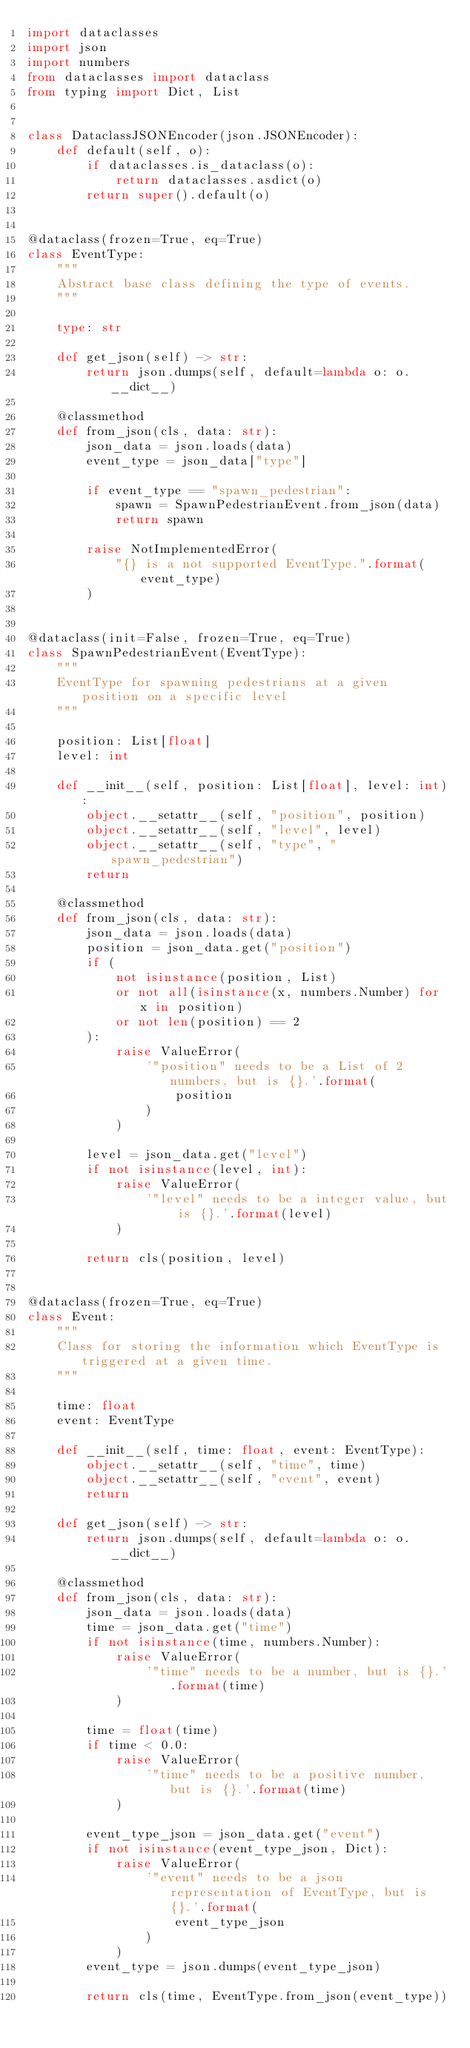Convert code to text. <code><loc_0><loc_0><loc_500><loc_500><_Python_>import dataclasses
import json
import numbers
from dataclasses import dataclass
from typing import Dict, List


class DataclassJSONEncoder(json.JSONEncoder):
    def default(self, o):
        if dataclasses.is_dataclass(o):
            return dataclasses.asdict(o)
        return super().default(o)


@dataclass(frozen=True, eq=True)
class EventType:
    """
    Abstract base class defining the type of events.
    """

    type: str

    def get_json(self) -> str:
        return json.dumps(self, default=lambda o: o.__dict__)

    @classmethod
    def from_json(cls, data: str):
        json_data = json.loads(data)
        event_type = json_data["type"]

        if event_type == "spawn_pedestrian":
            spawn = SpawnPedestrianEvent.from_json(data)
            return spawn

        raise NotImplementedError(
            "{} is a not supported EventType.".format(event_type)
        )


@dataclass(init=False, frozen=True, eq=True)
class SpawnPedestrianEvent(EventType):
    """
    EventType for spawning pedestrians at a given position on a specific level
    """

    position: List[float]
    level: int

    def __init__(self, position: List[float], level: int):
        object.__setattr__(self, "position", position)
        object.__setattr__(self, "level", level)
        object.__setattr__(self, "type", "spawn_pedestrian")
        return

    @classmethod
    def from_json(cls, data: str):
        json_data = json.loads(data)
        position = json_data.get("position")
        if (
            not isinstance(position, List)
            or not all(isinstance(x, numbers.Number) for x in position)
            or not len(position) == 2
        ):
            raise ValueError(
                '"position" needs to be a List of 2 numbers, but is {}.'.format(
                    position
                )
            )

        level = json_data.get("level")
        if not isinstance(level, int):
            raise ValueError(
                '"level" needs to be a integer value, but is {}.'.format(level)
            )

        return cls(position, level)


@dataclass(frozen=True, eq=True)
class Event:
    """
    Class for storing the information which EventType is triggered at a given time.
    """

    time: float
    event: EventType

    def __init__(self, time: float, event: EventType):
        object.__setattr__(self, "time", time)
        object.__setattr__(self, "event", event)
        return

    def get_json(self) -> str:
        return json.dumps(self, default=lambda o: o.__dict__)

    @classmethod
    def from_json(cls, data: str):
        json_data = json.loads(data)
        time = json_data.get("time")
        if not isinstance(time, numbers.Number):
            raise ValueError(
                '"time" needs to be a number, but is {}.'.format(time)
            )

        time = float(time)
        if time < 0.0:
            raise ValueError(
                '"time" needs to be a positive number, but is {}.'.format(time)
            )

        event_type_json = json_data.get("event")
        if not isinstance(event_type_json, Dict):
            raise ValueError(
                '"event" needs to be a json representation of EventType, but is {}.'.format(
                    event_type_json
                )
            )
        event_type = json.dumps(event_type_json)

        return cls(time, EventType.from_json(event_type))
</code> 